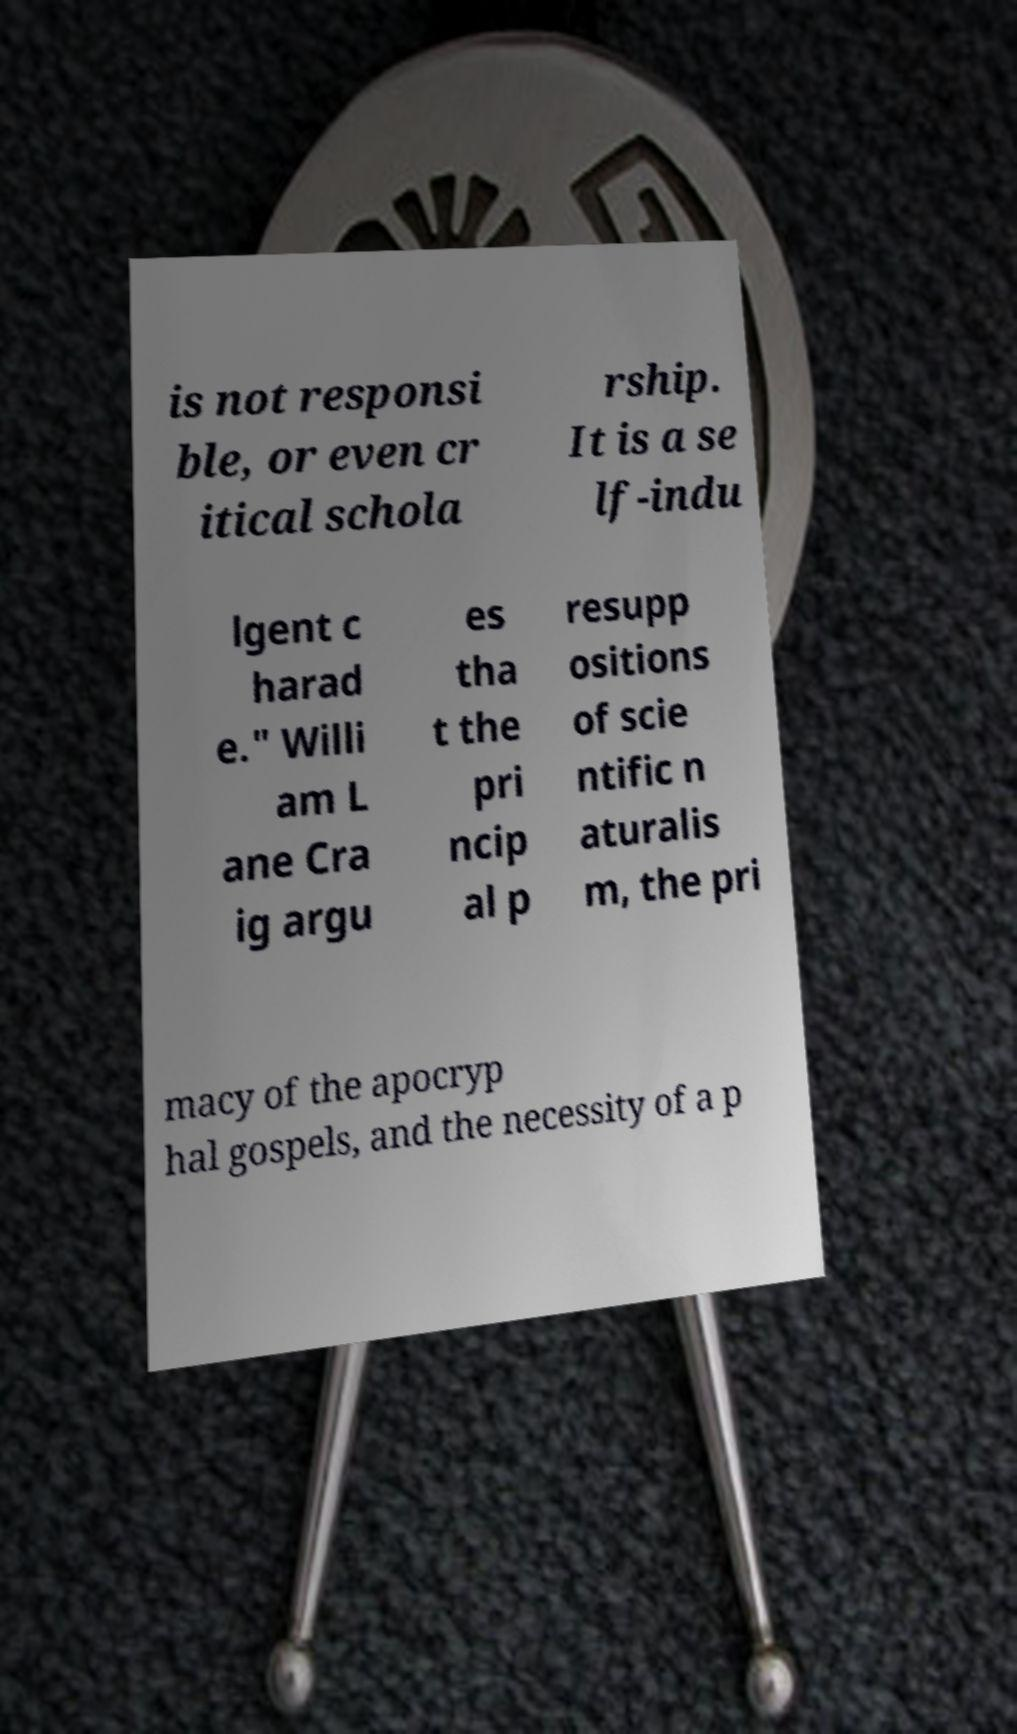I need the written content from this picture converted into text. Can you do that? is not responsi ble, or even cr itical schola rship. It is a se lf-indu lgent c harad e." Willi am L ane Cra ig argu es tha t the pri ncip al p resupp ositions of scie ntific n aturalis m, the pri macy of the apocryp hal gospels, and the necessity of a p 